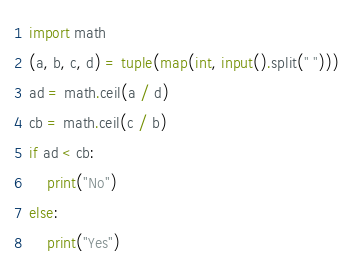Convert code to text. <code><loc_0><loc_0><loc_500><loc_500><_Python_>import math
(a, b, c, d) = tuple(map(int, input().split(" ")))
ad = math.ceil(a / d)
cb = math.ceil(c / b)
if ad < cb:
    print("No")
else:
    print("Yes")</code> 